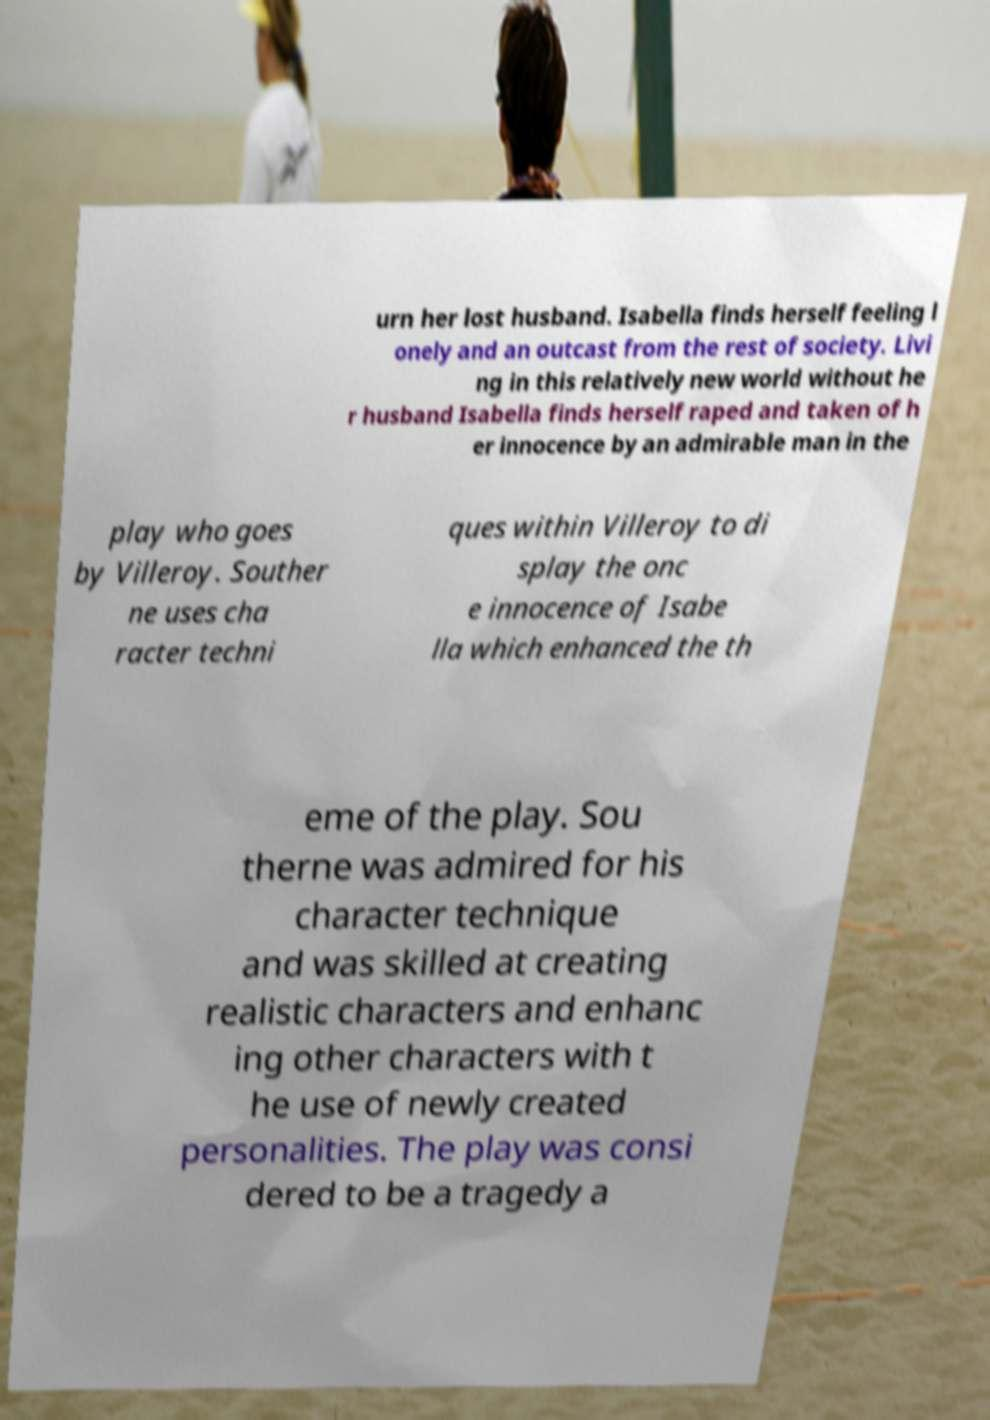What messages or text are displayed in this image? I need them in a readable, typed format. urn her lost husband. Isabella finds herself feeling l onely and an outcast from the rest of society. Livi ng in this relatively new world without he r husband Isabella finds herself raped and taken of h er innocence by an admirable man in the play who goes by Villeroy. Souther ne uses cha racter techni ques within Villeroy to di splay the onc e innocence of Isabe lla which enhanced the th eme of the play. Sou therne was admired for his character technique and was skilled at creating realistic characters and enhanc ing other characters with t he use of newly created personalities. The play was consi dered to be a tragedy a 